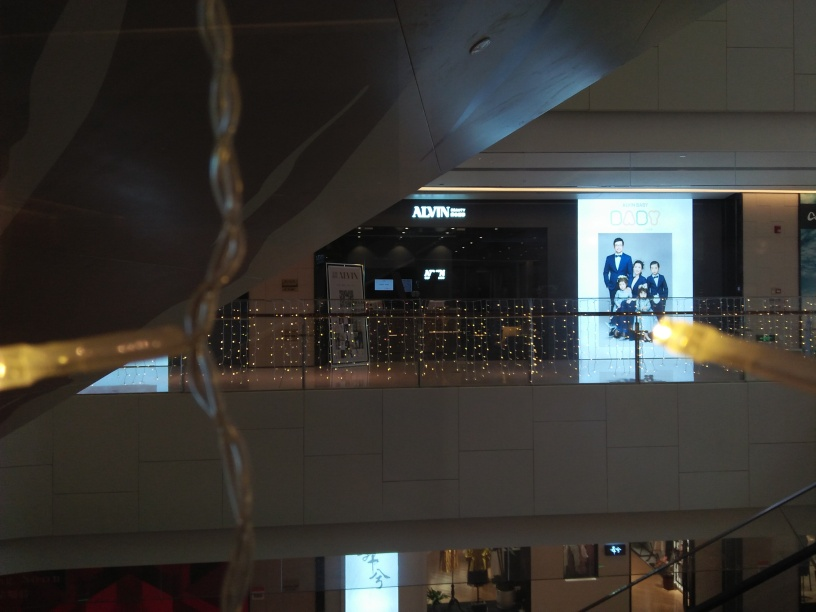Is the main subject clear in this image? The main subject of the image, which appears to be a lit advertisement or sign for a fashion brand, is not as clear as it could be. The brightness of the surrounding lights produces glare, causing the details of the sign to be less distinct. Moreover, the foreground elements contribute to a slightly obstructed view. Optimal clarity is not achieved; a more precise focus or angle might enhance the visibility of the main subject. Overall, I would say the clearness of the main subject is somewhere between slightly blurred and moderately defined. 